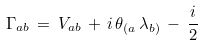<formula> <loc_0><loc_0><loc_500><loc_500>\Gamma _ { a b } \, = \, V _ { a b } \, + \, i \, \theta _ { ( a } \, \lambda _ { b ) } \, - \, \frac { i } { 2 }</formula> 